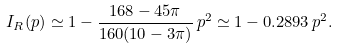<formula> <loc_0><loc_0><loc_500><loc_500>I _ { R } ( p ) \simeq 1 - \frac { 1 6 8 - 4 5 \pi } { 1 6 0 ( 1 0 - 3 \pi ) } \, p ^ { 2 } \simeq 1 - 0 . 2 8 9 3 \, p ^ { 2 } .</formula> 